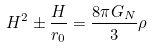Convert formula to latex. <formula><loc_0><loc_0><loc_500><loc_500>H ^ { 2 } \pm \frac { H } { r _ { 0 } } = \frac { 8 \pi G _ { N } } { 3 } \rho</formula> 